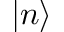Convert formula to latex. <formula><loc_0><loc_0><loc_500><loc_500>| n \rangle</formula> 